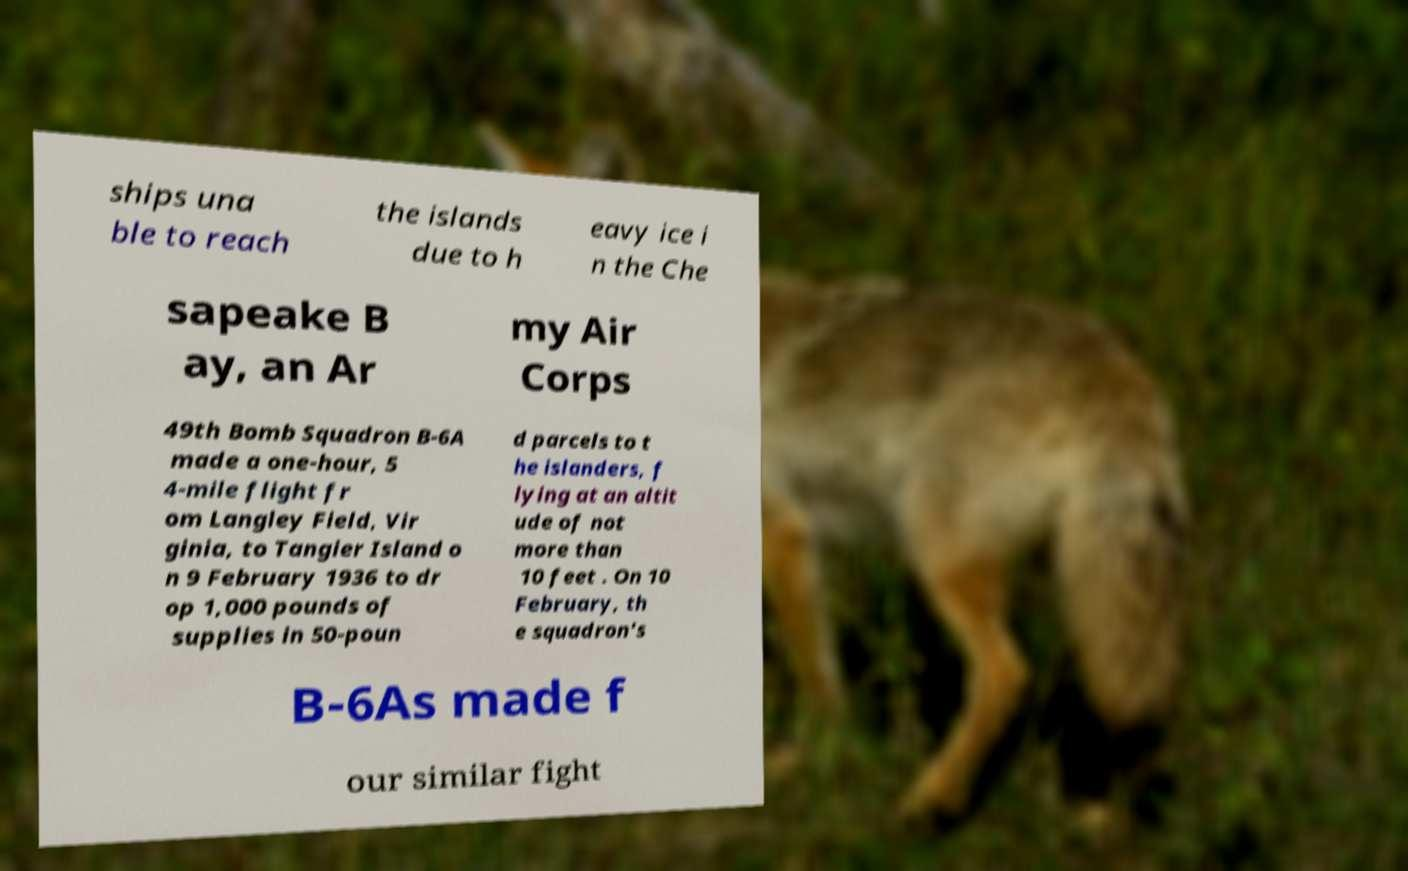For documentation purposes, I need the text within this image transcribed. Could you provide that? ships una ble to reach the islands due to h eavy ice i n the Che sapeake B ay, an Ar my Air Corps 49th Bomb Squadron B-6A made a one-hour, 5 4-mile flight fr om Langley Field, Vir ginia, to Tangier Island o n 9 February 1936 to dr op 1,000 pounds of supplies in 50-poun d parcels to t he islanders, f lying at an altit ude of not more than 10 feet . On 10 February, th e squadron's B-6As made f our similar fight 